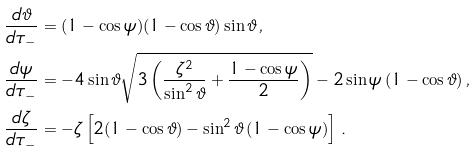Convert formula to latex. <formula><loc_0><loc_0><loc_500><loc_500>\frac { d \vartheta } { d \tau _ { - } } & = ( 1 - \cos \psi ) ( 1 - \cos \vartheta ) \sin \vartheta \, , \\ \frac { d \psi } { d \tau _ { - } } & = - 4 \sin \vartheta \sqrt { 3 \left ( \frac { \zeta ^ { 2 } } { \sin ^ { 2 } \vartheta } + \frac { 1 - \cos \psi } { 2 } \right ) } - 2 \sin \psi \, ( 1 - \cos \vartheta ) \, , \\ \frac { d \zeta } { d \tau _ { - } } & = - \zeta \left [ 2 ( 1 - \cos \vartheta ) - \sin ^ { 2 } \vartheta \, ( 1 - \cos \psi ) \right ] \, .</formula> 